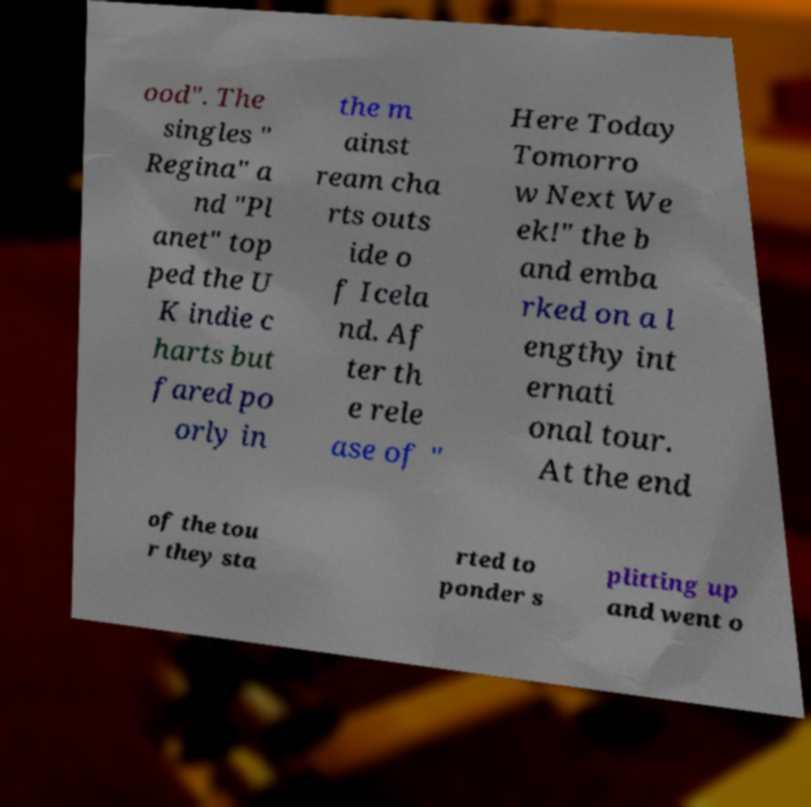What messages or text are displayed in this image? I need them in a readable, typed format. ood". The singles " Regina" a nd "Pl anet" top ped the U K indie c harts but fared po orly in the m ainst ream cha rts outs ide o f Icela nd. Af ter th e rele ase of " Here Today Tomorro w Next We ek!" the b and emba rked on a l engthy int ernati onal tour. At the end of the tou r they sta rted to ponder s plitting up and went o 